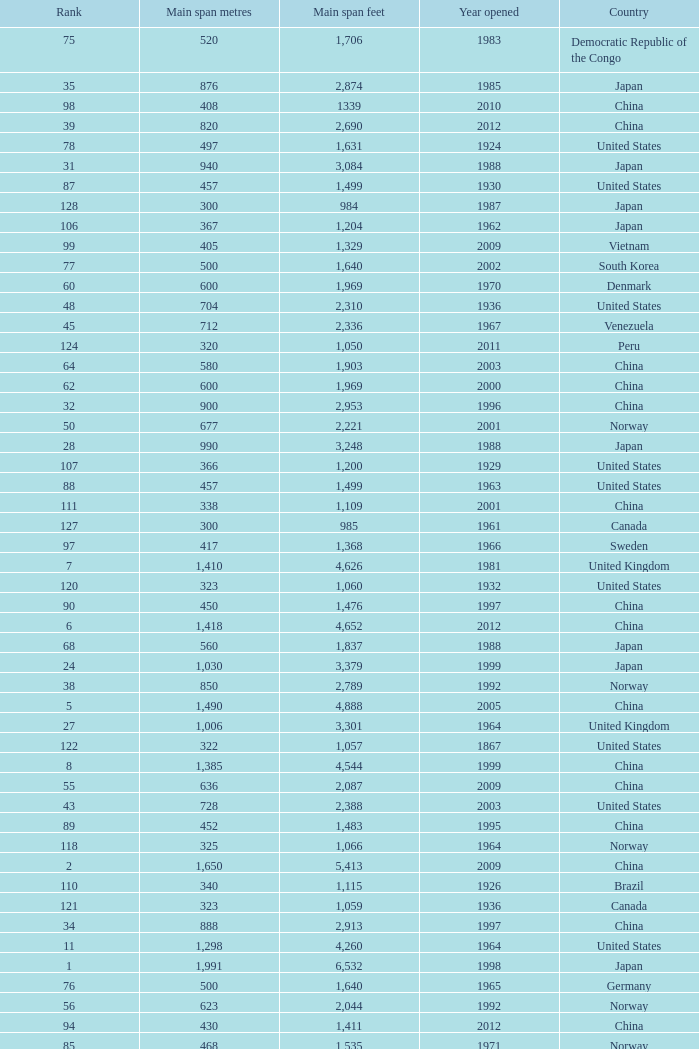What is the oldest year with a main span feet of 1,640 in South Korea? 2002.0. 